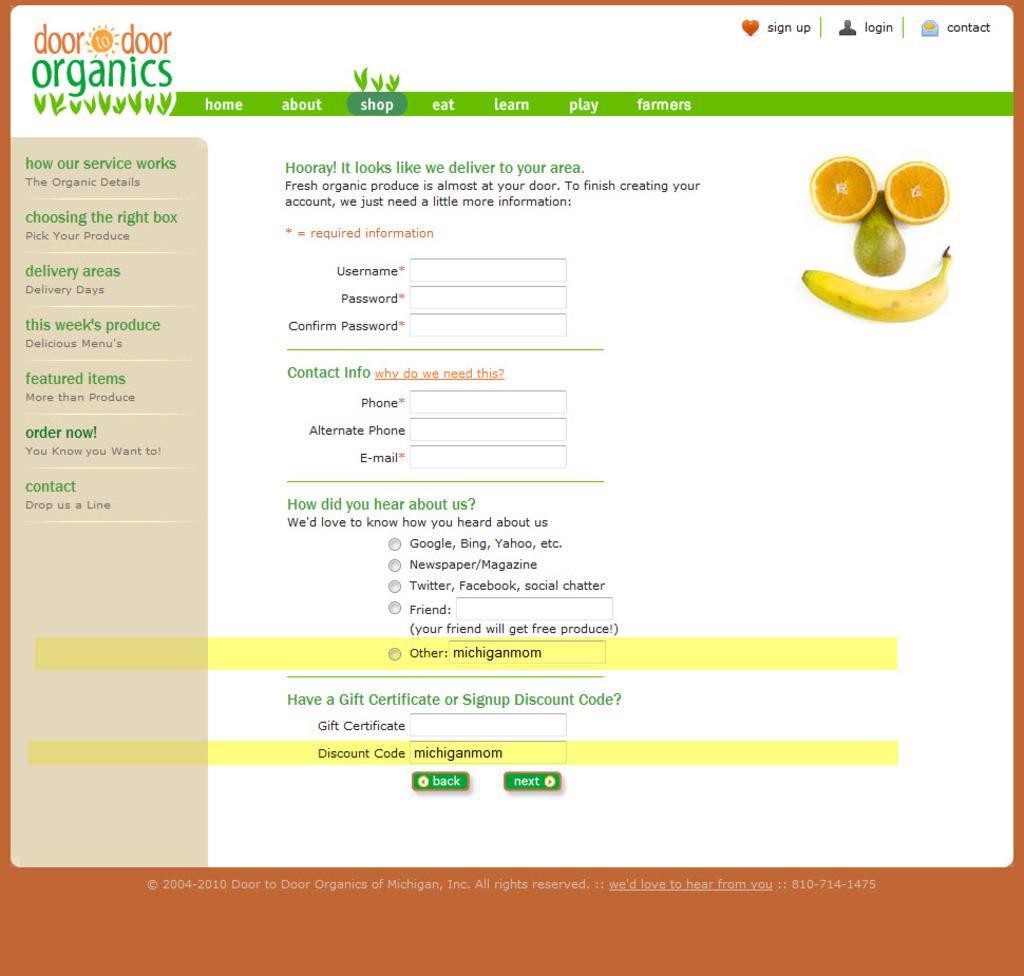Could you give a brief overview of what you see in this image? It is a web page of food delivery organisation. 